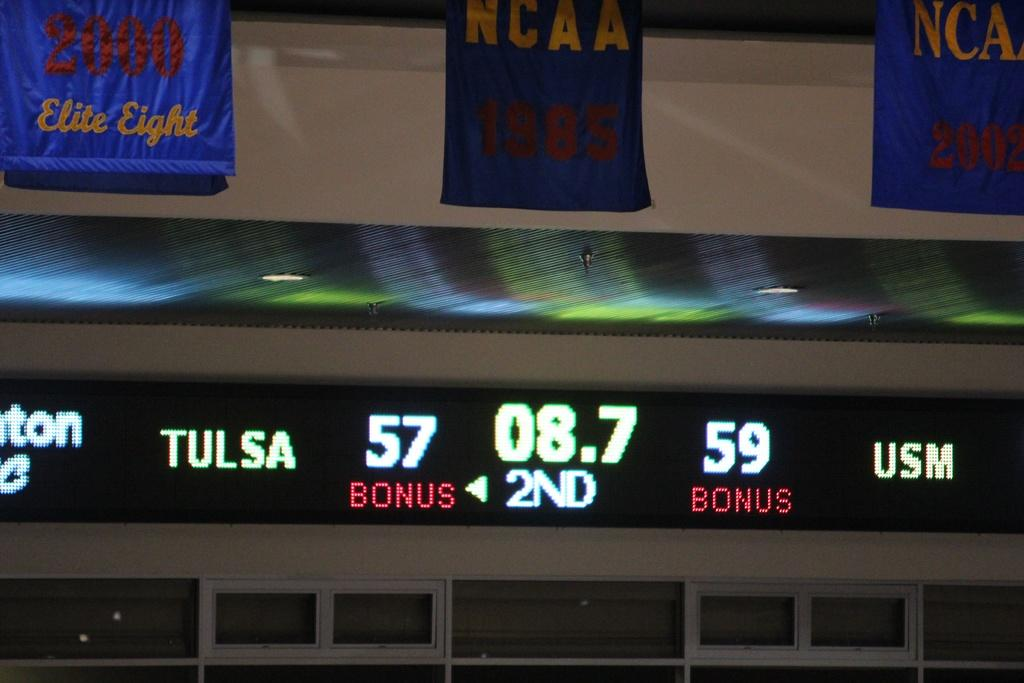<image>
Present a compact description of the photo's key features. Score board for Tulsa vs USM in the second quarter. 